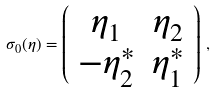<formula> <loc_0><loc_0><loc_500><loc_500>\sigma _ { 0 } ( \eta ) = \left ( \begin{array} { c c } \eta _ { 1 } & \eta _ { 2 } \\ - \eta ^ { \ast } _ { 2 } & \eta ^ { \ast } _ { 1 } \end{array} \right ) \, ,</formula> 